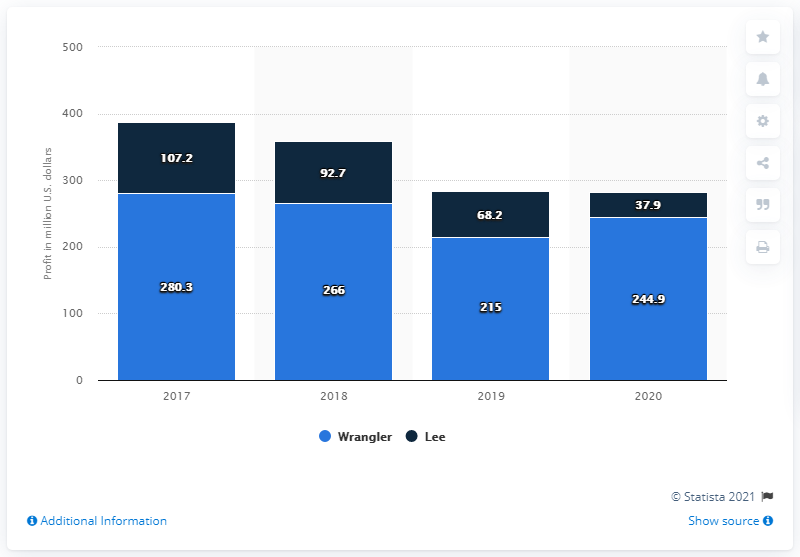Can you tell me the trend for Wrangler's revenue from 2017 to 2020 as shown in this chart? The bar chart displays a declining trend in Wrangler's revenue over the years provided, commencing with $280.3 million in 2017, descending to $266 million in 2018, followed by a drop to $215 million in 2019, and culminating with $244.9 million in 2020. Despite a slight increase in 2020, the overall trajectory is downward. 